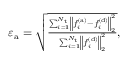<formula> <loc_0><loc_0><loc_500><loc_500>\begin{array} { r } { \varepsilon _ { a } = \sqrt { \frac { \sum _ { i = 1 } ^ { N _ { t } } \left \| f _ { i } ^ { ( a ) } - f _ { i } ^ { ( d ) } \right \| _ { 2 } ^ { 2 } } { \sum _ { i = 1 } ^ { N _ { t } } \left \| f _ { i } ^ { ( d ) } \right \| _ { 2 } ^ { 2 } } } , } \end{array}</formula> 